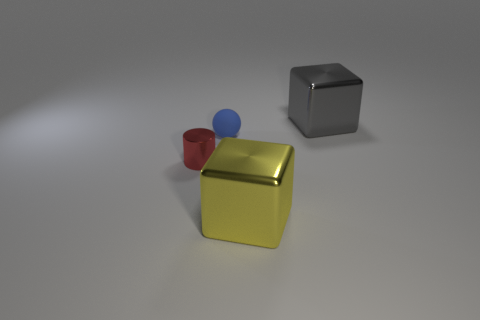Add 4 big gray blocks. How many objects exist? 8 Subtract all gray blocks. How many blocks are left? 1 Subtract all spheres. How many objects are left? 3 Subtract 1 blocks. How many blocks are left? 1 Subtract all large yellow metal cylinders. Subtract all big metallic blocks. How many objects are left? 2 Add 4 tiny cylinders. How many tiny cylinders are left? 5 Add 1 big yellow blocks. How many big yellow blocks exist? 2 Subtract 0 red balls. How many objects are left? 4 Subtract all yellow spheres. Subtract all blue cylinders. How many spheres are left? 1 